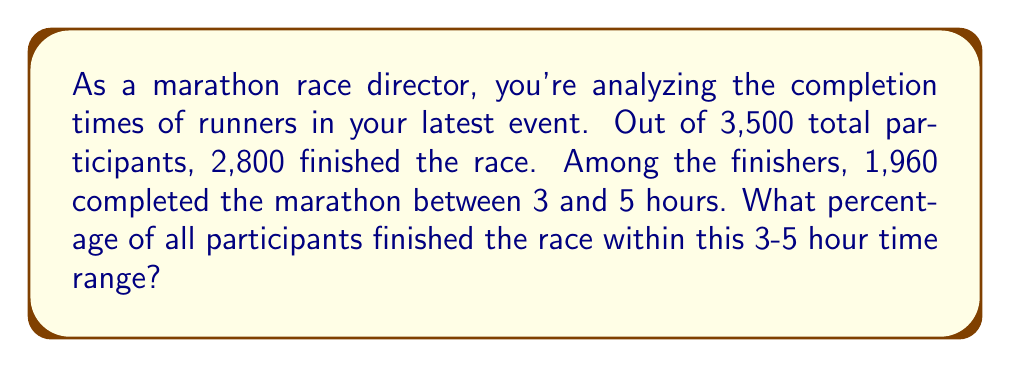Solve this math problem. To solve this problem, we'll follow these steps:

1. Identify the given information:
   - Total participants: 3,500
   - Total finishers: 2,800
   - Finishers between 3-5 hours: 1,960

2. Calculate the percentage of participants who finished between 3-5 hours:
   
   Let $x$ be the percentage we're looking for.
   
   $$x = \frac{\text{Finishers between 3-5 hours}}{\text{Total participants}} \times 100\%$$

   $$x = \frac{1,960}{3,500} \times 100\%$$

3. Simplify the fraction:
   
   $$x = \frac{196}{350} \times 100\%$$

4. Perform the division:
   
   $$x = 0.56 \times 100\% = 56\%$$

Therefore, 56% of all participants finished the race within the 3-5 hour time range.
Answer: 56% 